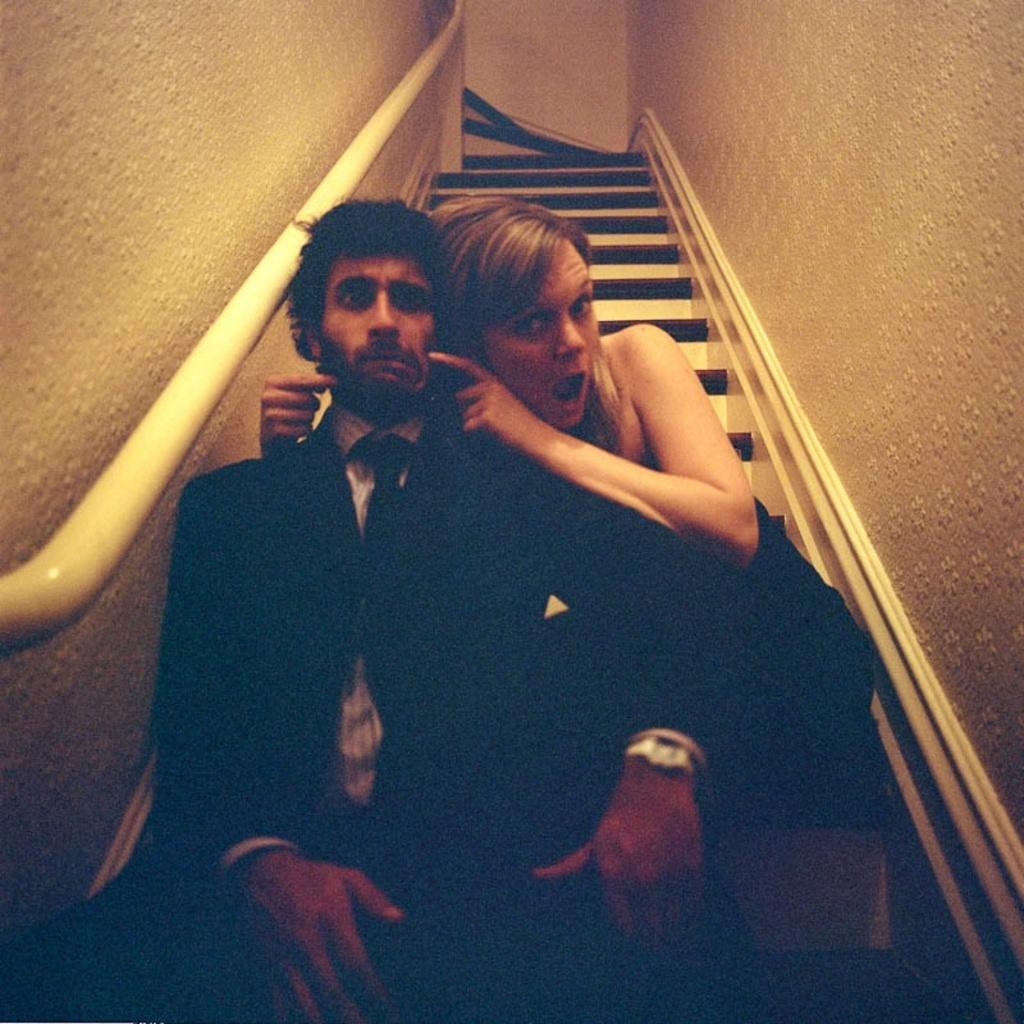How many people are present in the image? There are two people in the image, a man and a woman. What are the man and woman doing in the image? Both the man and woman are sitting on a staircase. What can be seen on either side of the image? There is a wall on the left side of the image and a wall on the right side of the image. What type of rings can be seen on the writer's fingers in the image? There is no writer present in the image, and therefore no rings can be seen on their fingers. 